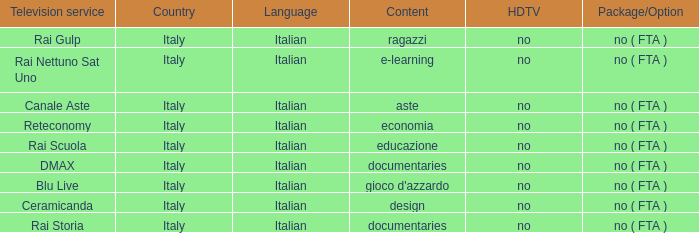What is the Language for Canale Aste? Italian. Help me parse the entirety of this table. {'header': ['Television service', 'Country', 'Language', 'Content', 'HDTV', 'Package/Option'], 'rows': [['Rai Gulp', 'Italy', 'Italian', 'ragazzi', 'no', 'no ( FTA )'], ['Rai Nettuno Sat Uno', 'Italy', 'Italian', 'e-learning', 'no', 'no ( FTA )'], ['Canale Aste', 'Italy', 'Italian', 'aste', 'no', 'no ( FTA )'], ['Reteconomy', 'Italy', 'Italian', 'economia', 'no', 'no ( FTA )'], ['Rai Scuola', 'Italy', 'Italian', 'educazione', 'no', 'no ( FTA )'], ['DMAX', 'Italy', 'Italian', 'documentaries', 'no', 'no ( FTA )'], ['Blu Live', 'Italy', 'Italian', "gioco d'azzardo", 'no', 'no ( FTA )'], ['Ceramicanda', 'Italy', 'Italian', 'design', 'no', 'no ( FTA )'], ['Rai Storia', 'Italy', 'Italian', 'documentaries', 'no', 'no ( FTA )']]} 